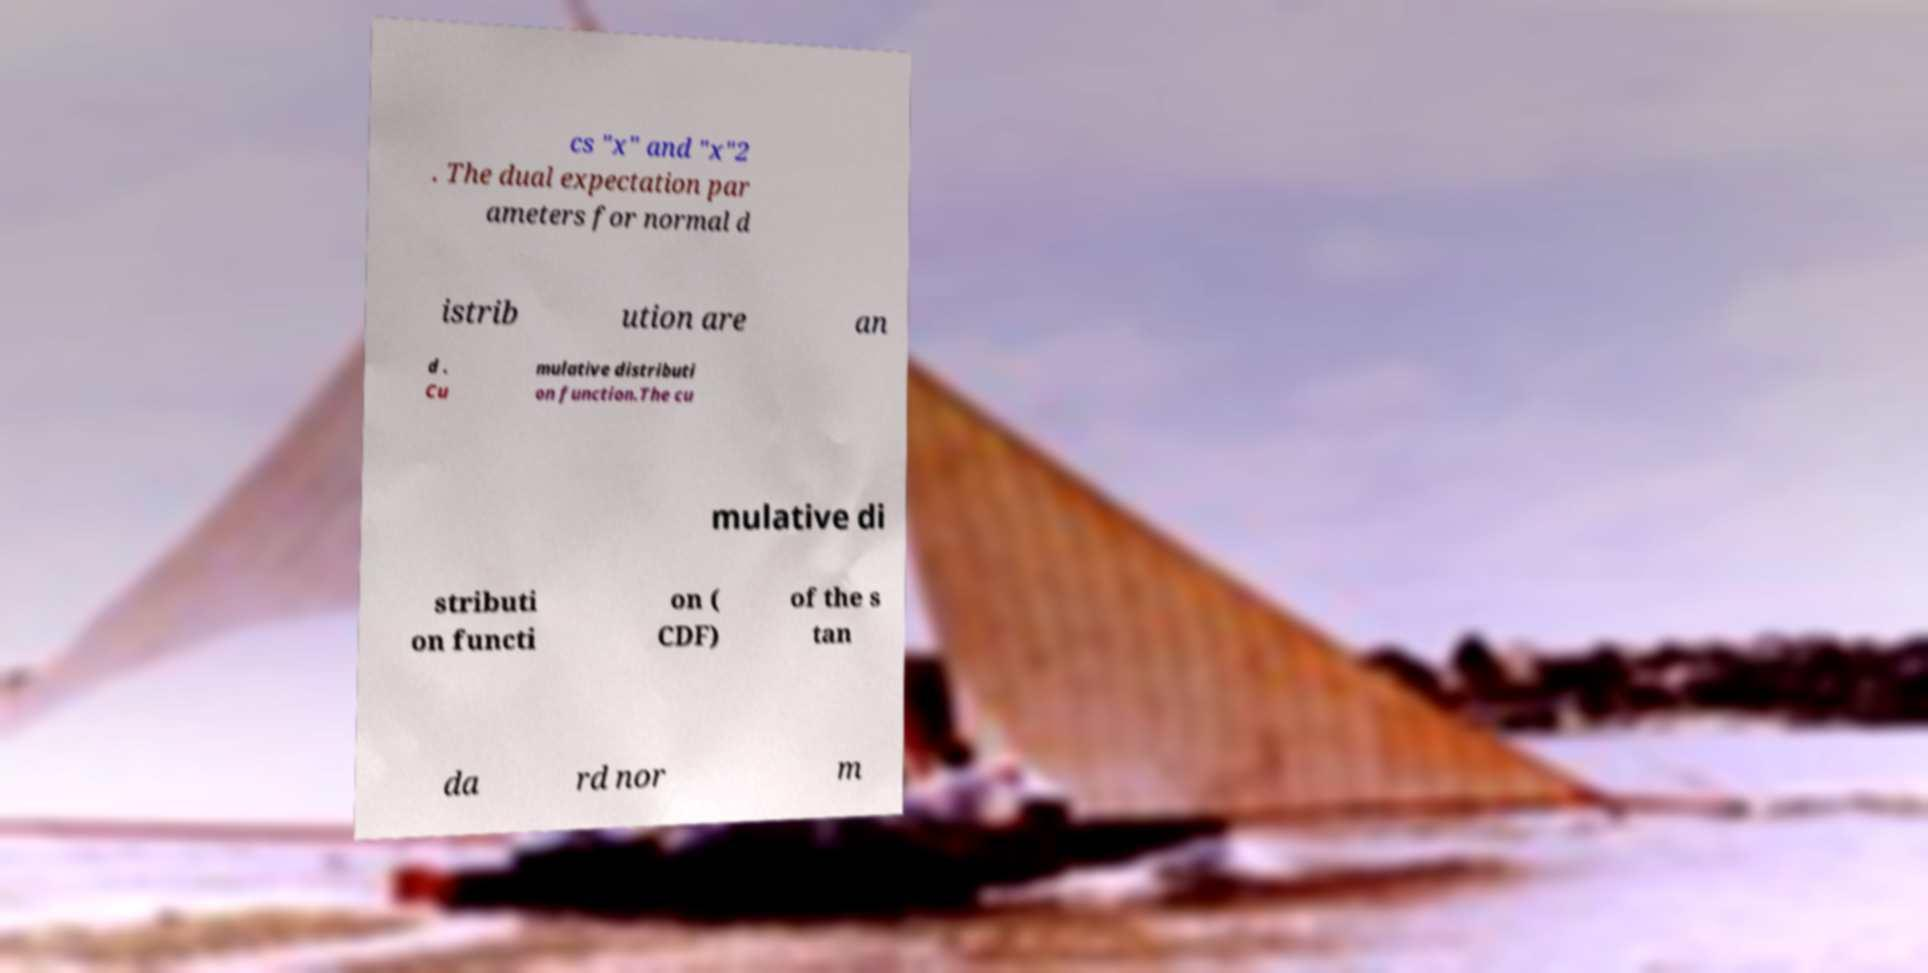Can you read and provide the text displayed in the image?This photo seems to have some interesting text. Can you extract and type it out for me? cs "x" and "x"2 . The dual expectation par ameters for normal d istrib ution are an d . Cu mulative distributi on function.The cu mulative di stributi on functi on ( CDF) of the s tan da rd nor m 